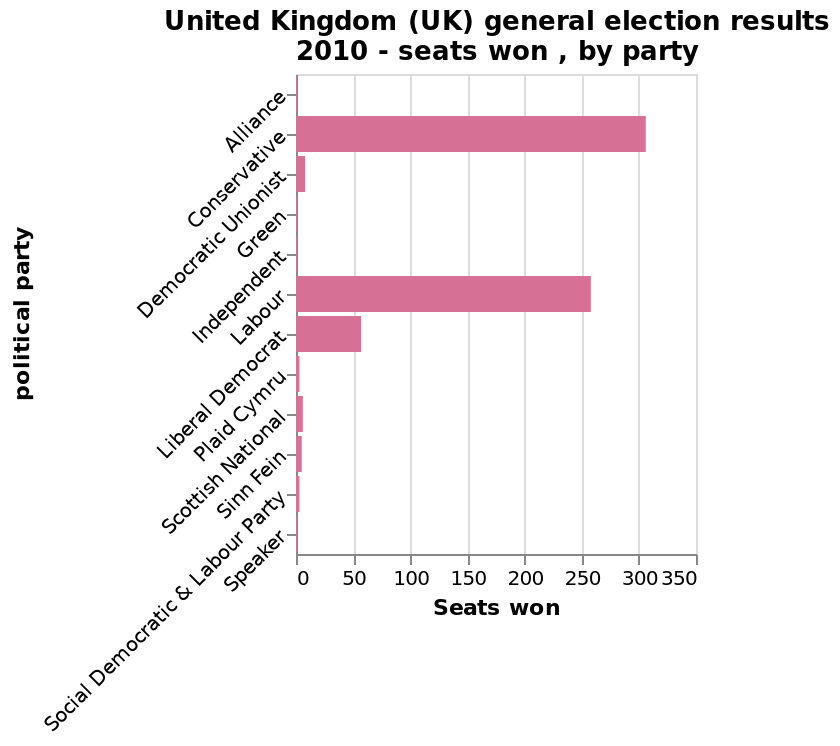<image>
Which party had the least number of seats? The description does not specify which party had the least number of seats. Did the Conservative party win more seats than Labour?  Yes, the Conservative party won more seats than Labour. Did the Conservative party win fewer seats than Labour? No. Yes, the Conservative party won more seats than Labour. 